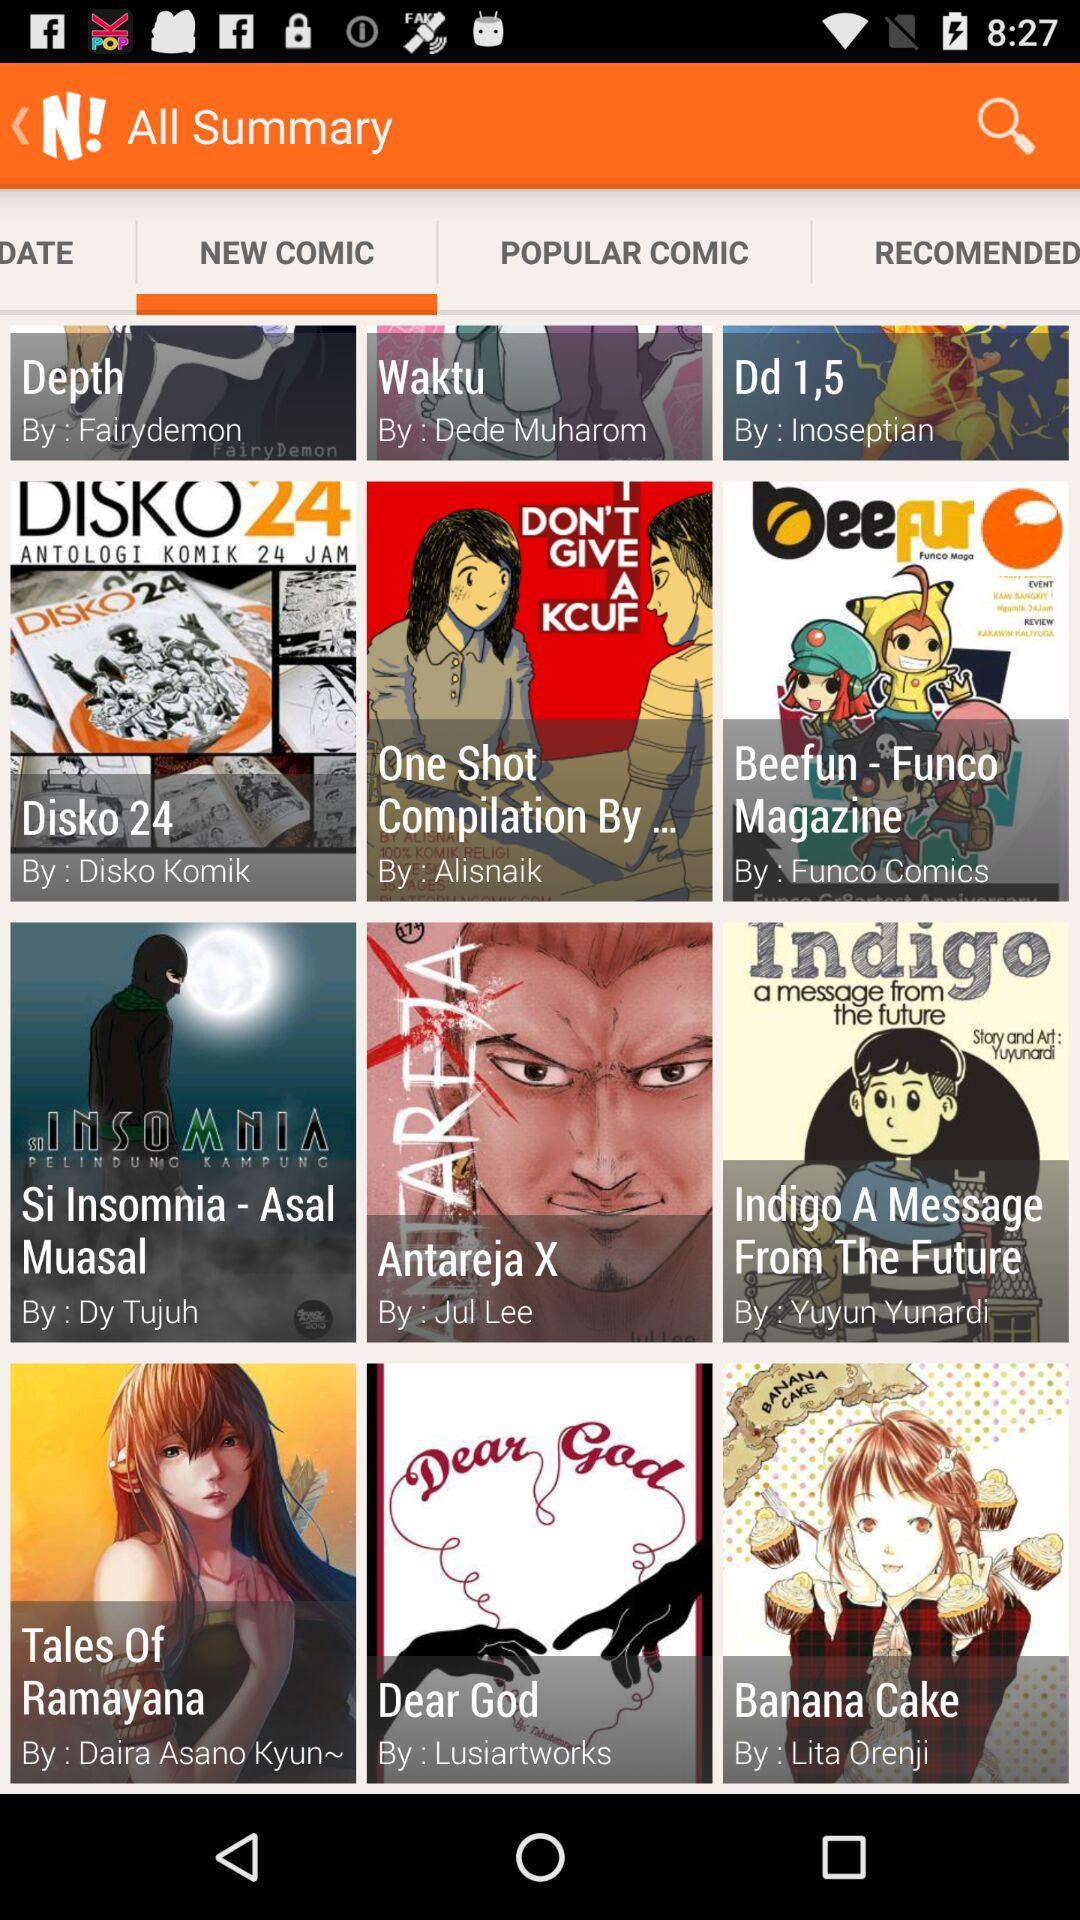Which comic is written by "Disko Komik"? The comic that is written by "Disko Komik" is "Disko 24". 